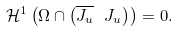<formula> <loc_0><loc_0><loc_500><loc_500>\mathcal { H } ^ { 1 } \left ( \Omega \cap \left ( \overline { J _ { u } } \ J _ { u } \right ) \right ) = 0 .</formula> 